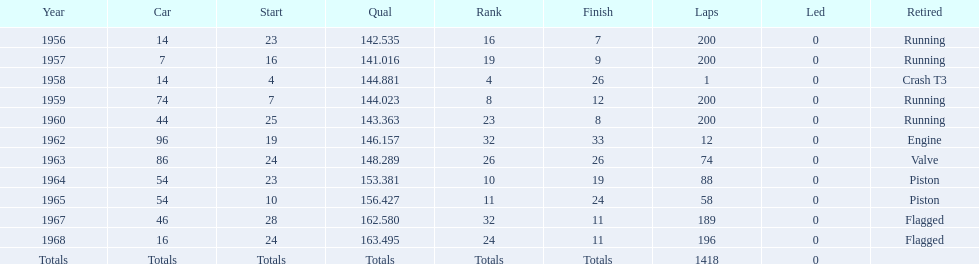In the indy 500, how many instances were there of bob veith being ranked in the top 10? 2. 